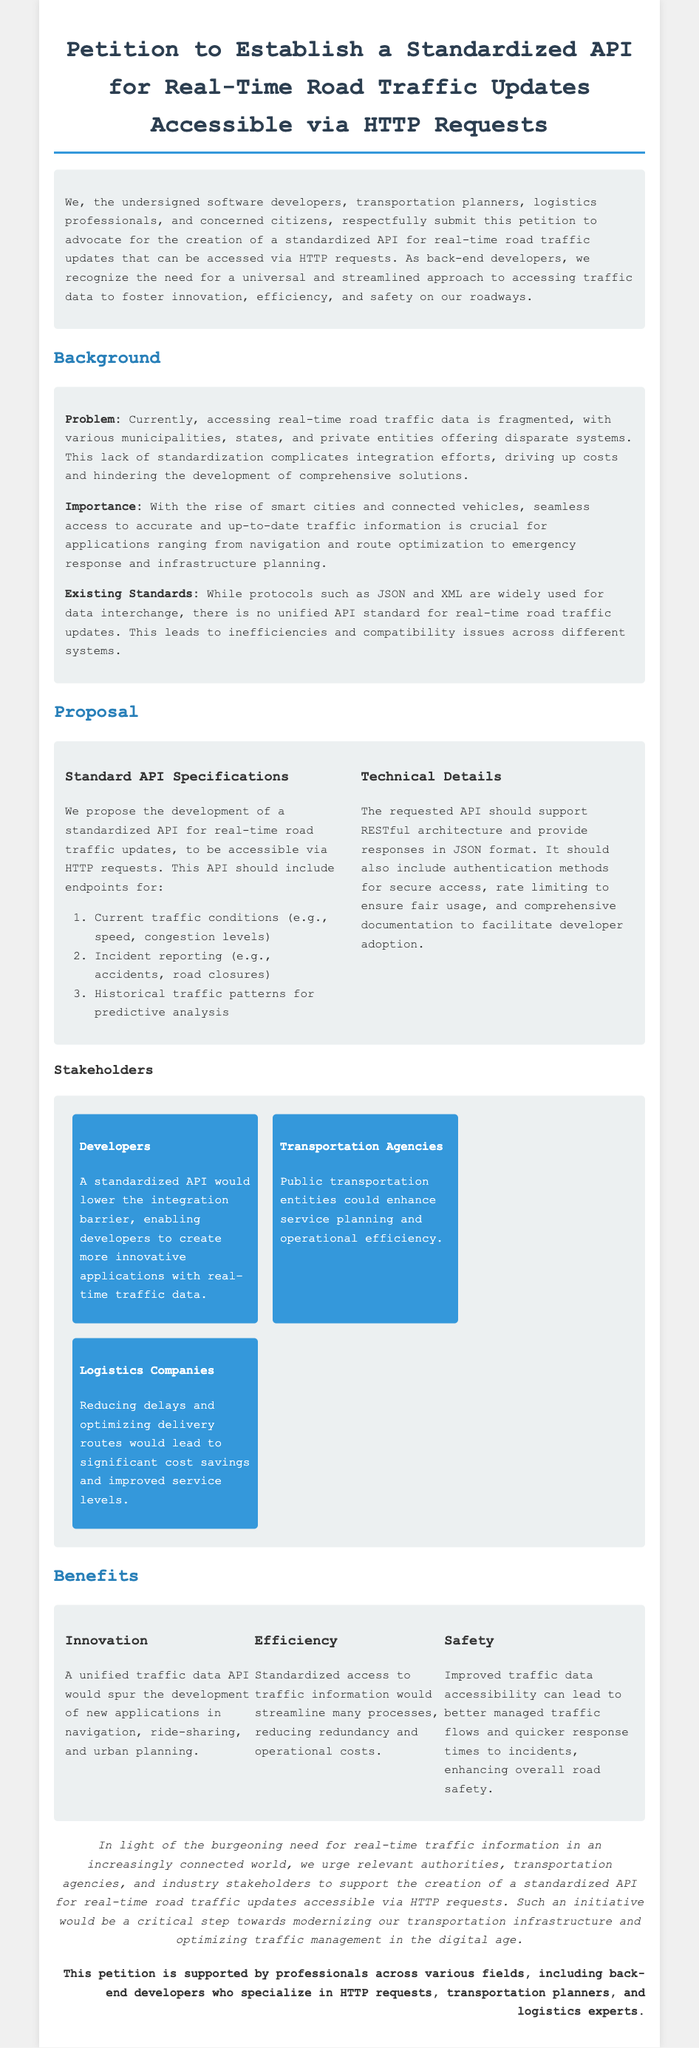What is the main purpose of the petition? The petition advocates for the creation of a standardized API for real-time road traffic updates accessible via HTTP requests.
Answer: Standardized API for real-time road traffic updates Who are the proposed stakeholders mentioned in the document? The document lists developers, transportation agencies, and logistics companies as stakeholders.
Answer: Developers, transportation agencies, logistics companies How many specific endpoints for the API are proposed? The document lists three endpoints: current traffic conditions, incident reporting, and historical traffic patterns.
Answer: Three What type of data format is requested for the API responses? The proposal specifies that the API should provide responses in JSON format.
Answer: JSON What is one key benefit of a unified traffic data API? The document states that a unified traffic data API would spur the development of new applications in navigation, ride-sharing, and urban planning.
Answer: Innovation What architecture should the requested API support? The petition outlines that the API should support RESTful architecture.
Answer: RESTful architecture What is the concluding call to action in the petition? The petition urges relevant authorities and stakeholders to support the creation of the standardized API for traffic updates.
Answer: Support the creation of the standardized API Which professional group is explicitly mentioned in the petition as supporters? The document specifically mentions back-end developers who specialize in HTTP requests as part of the supporters.
Answer: Back-end developers 